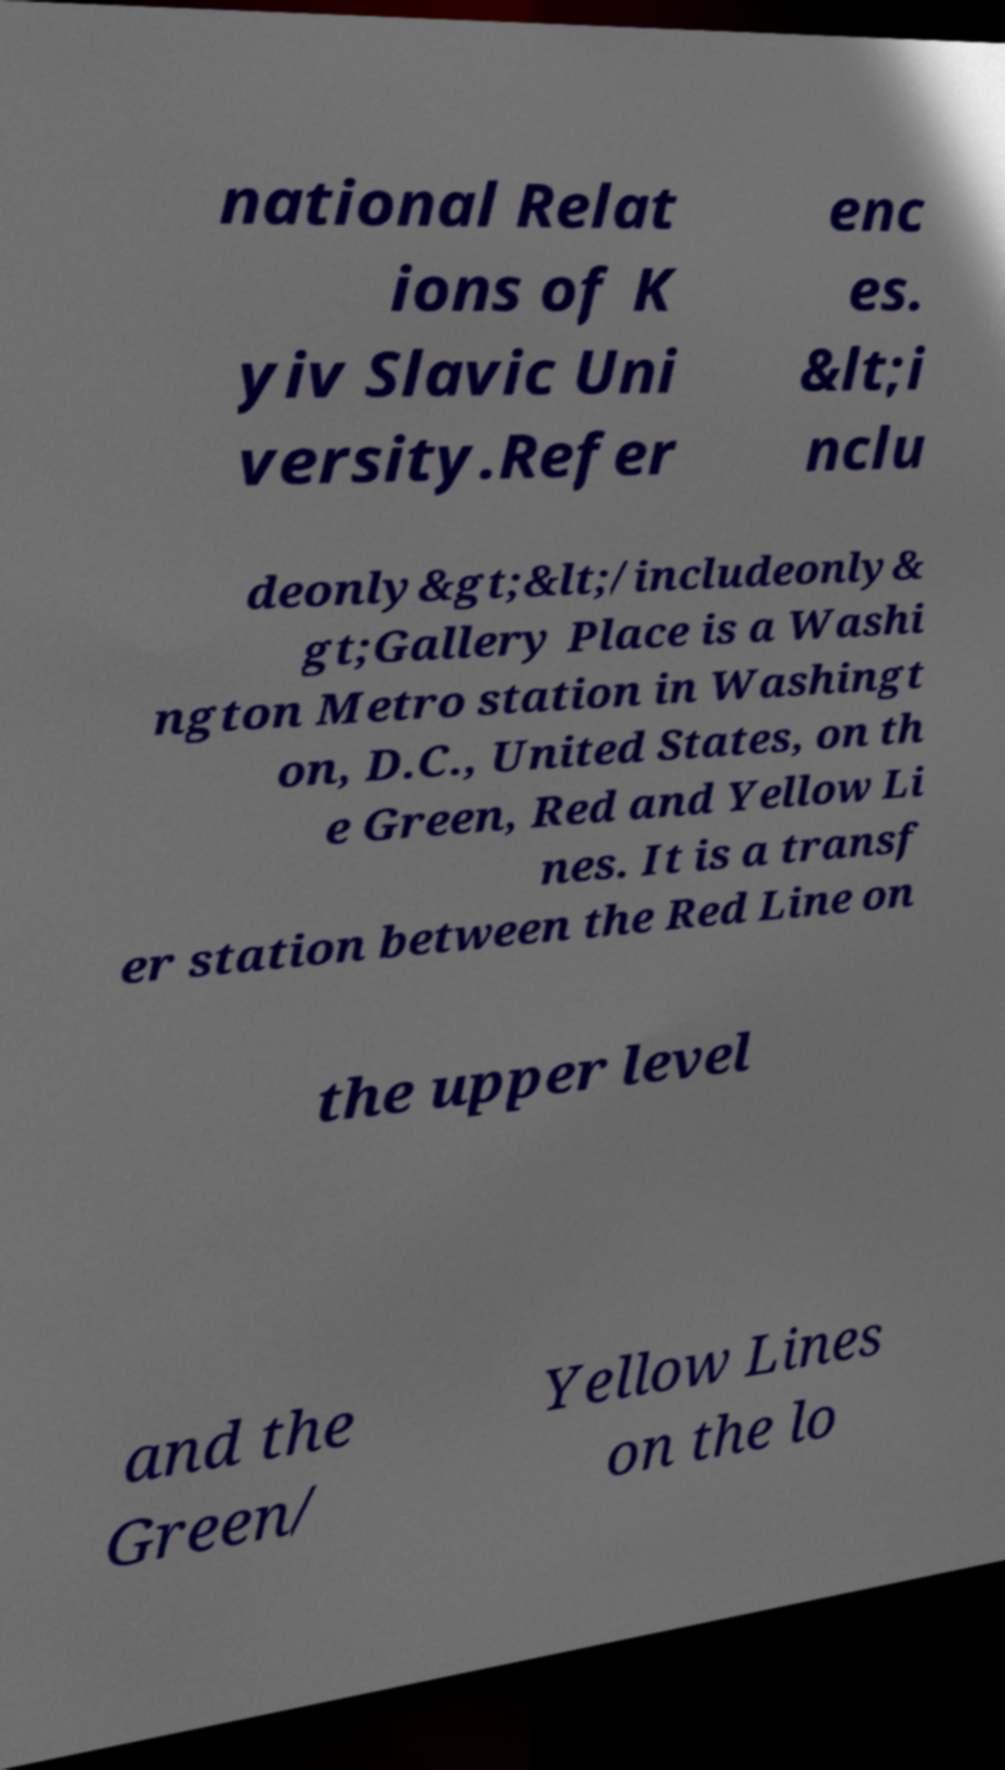Could you assist in decoding the text presented in this image and type it out clearly? national Relat ions of K yiv Slavic Uni versity.Refer enc es. &lt;i nclu deonly&gt;&lt;/includeonly& gt;Gallery Place is a Washi ngton Metro station in Washingt on, D.C., United States, on th e Green, Red and Yellow Li nes. It is a transf er station between the Red Line on the upper level and the Green/ Yellow Lines on the lo 